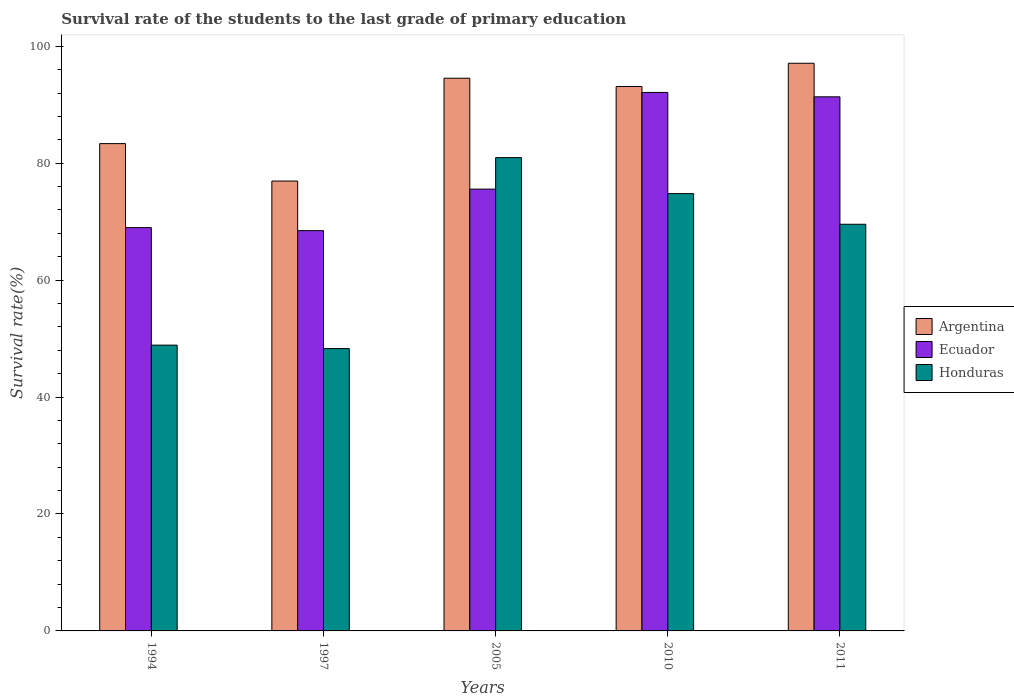How many different coloured bars are there?
Keep it short and to the point. 3. How many bars are there on the 5th tick from the left?
Your answer should be very brief. 3. How many bars are there on the 4th tick from the right?
Give a very brief answer. 3. In how many cases, is the number of bars for a given year not equal to the number of legend labels?
Give a very brief answer. 0. What is the survival rate of the students in Argentina in 2010?
Keep it short and to the point. 93.12. Across all years, what is the maximum survival rate of the students in Honduras?
Make the answer very short. 80.96. Across all years, what is the minimum survival rate of the students in Argentina?
Your answer should be compact. 76.95. In which year was the survival rate of the students in Ecuador maximum?
Keep it short and to the point. 2010. What is the total survival rate of the students in Ecuador in the graph?
Offer a terse response. 396.48. What is the difference between the survival rate of the students in Honduras in 2010 and that in 2011?
Provide a short and direct response. 5.24. What is the difference between the survival rate of the students in Argentina in 2011 and the survival rate of the students in Ecuador in 1997?
Your response must be concise. 28.63. What is the average survival rate of the students in Argentina per year?
Ensure brevity in your answer.  89.01. In the year 2005, what is the difference between the survival rate of the students in Ecuador and survival rate of the students in Argentina?
Provide a short and direct response. -18.97. What is the ratio of the survival rate of the students in Ecuador in 2010 to that in 2011?
Your response must be concise. 1.01. Is the survival rate of the students in Argentina in 1994 less than that in 2010?
Give a very brief answer. Yes. What is the difference between the highest and the second highest survival rate of the students in Ecuador?
Your response must be concise. 0.75. What is the difference between the highest and the lowest survival rate of the students in Ecuador?
Ensure brevity in your answer.  23.63. Is the sum of the survival rate of the students in Argentina in 1997 and 2005 greater than the maximum survival rate of the students in Ecuador across all years?
Your answer should be compact. Yes. What does the 1st bar from the right in 2010 represents?
Your answer should be very brief. Honduras. Are all the bars in the graph horizontal?
Your answer should be compact. No. Does the graph contain grids?
Your answer should be compact. No. How many legend labels are there?
Make the answer very short. 3. What is the title of the graph?
Provide a succinct answer. Survival rate of the students to the last grade of primary education. Does "Bosnia and Herzegovina" appear as one of the legend labels in the graph?
Provide a short and direct response. No. What is the label or title of the X-axis?
Offer a terse response. Years. What is the label or title of the Y-axis?
Provide a short and direct response. Survival rate(%). What is the Survival rate(%) in Argentina in 1994?
Your response must be concise. 83.35. What is the Survival rate(%) of Ecuador in 1994?
Offer a terse response. 68.98. What is the Survival rate(%) of Honduras in 1994?
Ensure brevity in your answer.  48.88. What is the Survival rate(%) in Argentina in 1997?
Make the answer very short. 76.95. What is the Survival rate(%) of Ecuador in 1997?
Ensure brevity in your answer.  68.47. What is the Survival rate(%) in Honduras in 1997?
Your answer should be very brief. 48.29. What is the Survival rate(%) in Argentina in 2005?
Your response must be concise. 94.54. What is the Survival rate(%) of Ecuador in 2005?
Your answer should be very brief. 75.57. What is the Survival rate(%) of Honduras in 2005?
Your answer should be very brief. 80.96. What is the Survival rate(%) in Argentina in 2010?
Provide a short and direct response. 93.12. What is the Survival rate(%) of Ecuador in 2010?
Offer a terse response. 92.1. What is the Survival rate(%) in Honduras in 2010?
Provide a short and direct response. 74.8. What is the Survival rate(%) in Argentina in 2011?
Your answer should be compact. 97.1. What is the Survival rate(%) in Ecuador in 2011?
Provide a short and direct response. 91.36. What is the Survival rate(%) in Honduras in 2011?
Offer a very short reply. 69.56. Across all years, what is the maximum Survival rate(%) in Argentina?
Give a very brief answer. 97.1. Across all years, what is the maximum Survival rate(%) of Ecuador?
Make the answer very short. 92.1. Across all years, what is the maximum Survival rate(%) of Honduras?
Provide a short and direct response. 80.96. Across all years, what is the minimum Survival rate(%) of Argentina?
Give a very brief answer. 76.95. Across all years, what is the minimum Survival rate(%) of Ecuador?
Offer a terse response. 68.47. Across all years, what is the minimum Survival rate(%) in Honduras?
Make the answer very short. 48.29. What is the total Survival rate(%) in Argentina in the graph?
Offer a very short reply. 445.06. What is the total Survival rate(%) in Ecuador in the graph?
Provide a short and direct response. 396.48. What is the total Survival rate(%) in Honduras in the graph?
Ensure brevity in your answer.  322.49. What is the difference between the Survival rate(%) of Argentina in 1994 and that in 1997?
Ensure brevity in your answer.  6.4. What is the difference between the Survival rate(%) in Ecuador in 1994 and that in 1997?
Offer a very short reply. 0.51. What is the difference between the Survival rate(%) of Honduras in 1994 and that in 1997?
Your answer should be very brief. 0.59. What is the difference between the Survival rate(%) in Argentina in 1994 and that in 2005?
Your answer should be very brief. -11.19. What is the difference between the Survival rate(%) of Ecuador in 1994 and that in 2005?
Offer a terse response. -6.59. What is the difference between the Survival rate(%) in Honduras in 1994 and that in 2005?
Provide a short and direct response. -32.07. What is the difference between the Survival rate(%) of Argentina in 1994 and that in 2010?
Make the answer very short. -9.76. What is the difference between the Survival rate(%) of Ecuador in 1994 and that in 2010?
Offer a very short reply. -23.12. What is the difference between the Survival rate(%) of Honduras in 1994 and that in 2010?
Make the answer very short. -25.92. What is the difference between the Survival rate(%) of Argentina in 1994 and that in 2011?
Your answer should be very brief. -13.74. What is the difference between the Survival rate(%) in Ecuador in 1994 and that in 2011?
Provide a succinct answer. -22.37. What is the difference between the Survival rate(%) of Honduras in 1994 and that in 2011?
Keep it short and to the point. -20.68. What is the difference between the Survival rate(%) in Argentina in 1997 and that in 2005?
Make the answer very short. -17.59. What is the difference between the Survival rate(%) of Ecuador in 1997 and that in 2005?
Your answer should be compact. -7.1. What is the difference between the Survival rate(%) in Honduras in 1997 and that in 2005?
Offer a very short reply. -32.66. What is the difference between the Survival rate(%) of Argentina in 1997 and that in 2010?
Make the answer very short. -16.17. What is the difference between the Survival rate(%) in Ecuador in 1997 and that in 2010?
Your response must be concise. -23.63. What is the difference between the Survival rate(%) in Honduras in 1997 and that in 2010?
Provide a short and direct response. -26.51. What is the difference between the Survival rate(%) of Argentina in 1997 and that in 2011?
Offer a terse response. -20.15. What is the difference between the Survival rate(%) in Ecuador in 1997 and that in 2011?
Provide a succinct answer. -22.89. What is the difference between the Survival rate(%) of Honduras in 1997 and that in 2011?
Keep it short and to the point. -21.26. What is the difference between the Survival rate(%) of Argentina in 2005 and that in 2010?
Provide a succinct answer. 1.42. What is the difference between the Survival rate(%) of Ecuador in 2005 and that in 2010?
Ensure brevity in your answer.  -16.53. What is the difference between the Survival rate(%) in Honduras in 2005 and that in 2010?
Ensure brevity in your answer.  6.16. What is the difference between the Survival rate(%) in Argentina in 2005 and that in 2011?
Your response must be concise. -2.56. What is the difference between the Survival rate(%) in Ecuador in 2005 and that in 2011?
Keep it short and to the point. -15.78. What is the difference between the Survival rate(%) of Honduras in 2005 and that in 2011?
Give a very brief answer. 11.4. What is the difference between the Survival rate(%) of Argentina in 2010 and that in 2011?
Keep it short and to the point. -3.98. What is the difference between the Survival rate(%) in Ecuador in 2010 and that in 2011?
Keep it short and to the point. 0.75. What is the difference between the Survival rate(%) in Honduras in 2010 and that in 2011?
Offer a terse response. 5.24. What is the difference between the Survival rate(%) in Argentina in 1994 and the Survival rate(%) in Ecuador in 1997?
Your answer should be compact. 14.88. What is the difference between the Survival rate(%) of Argentina in 1994 and the Survival rate(%) of Honduras in 1997?
Make the answer very short. 35.06. What is the difference between the Survival rate(%) in Ecuador in 1994 and the Survival rate(%) in Honduras in 1997?
Provide a succinct answer. 20.69. What is the difference between the Survival rate(%) in Argentina in 1994 and the Survival rate(%) in Ecuador in 2005?
Provide a succinct answer. 7.78. What is the difference between the Survival rate(%) of Argentina in 1994 and the Survival rate(%) of Honduras in 2005?
Offer a very short reply. 2.4. What is the difference between the Survival rate(%) of Ecuador in 1994 and the Survival rate(%) of Honduras in 2005?
Provide a short and direct response. -11.97. What is the difference between the Survival rate(%) in Argentina in 1994 and the Survival rate(%) in Ecuador in 2010?
Your answer should be compact. -8.75. What is the difference between the Survival rate(%) in Argentina in 1994 and the Survival rate(%) in Honduras in 2010?
Your response must be concise. 8.55. What is the difference between the Survival rate(%) of Ecuador in 1994 and the Survival rate(%) of Honduras in 2010?
Provide a succinct answer. -5.82. What is the difference between the Survival rate(%) of Argentina in 1994 and the Survival rate(%) of Ecuador in 2011?
Your answer should be compact. -8. What is the difference between the Survival rate(%) of Argentina in 1994 and the Survival rate(%) of Honduras in 2011?
Offer a very short reply. 13.8. What is the difference between the Survival rate(%) in Ecuador in 1994 and the Survival rate(%) in Honduras in 2011?
Ensure brevity in your answer.  -0.57. What is the difference between the Survival rate(%) of Argentina in 1997 and the Survival rate(%) of Ecuador in 2005?
Make the answer very short. 1.38. What is the difference between the Survival rate(%) in Argentina in 1997 and the Survival rate(%) in Honduras in 2005?
Offer a terse response. -4.01. What is the difference between the Survival rate(%) of Ecuador in 1997 and the Survival rate(%) of Honduras in 2005?
Give a very brief answer. -12.49. What is the difference between the Survival rate(%) of Argentina in 1997 and the Survival rate(%) of Ecuador in 2010?
Make the answer very short. -15.15. What is the difference between the Survival rate(%) in Argentina in 1997 and the Survival rate(%) in Honduras in 2010?
Your answer should be compact. 2.15. What is the difference between the Survival rate(%) in Ecuador in 1997 and the Survival rate(%) in Honduras in 2010?
Your response must be concise. -6.33. What is the difference between the Survival rate(%) in Argentina in 1997 and the Survival rate(%) in Ecuador in 2011?
Offer a terse response. -14.41. What is the difference between the Survival rate(%) of Argentina in 1997 and the Survival rate(%) of Honduras in 2011?
Keep it short and to the point. 7.39. What is the difference between the Survival rate(%) in Ecuador in 1997 and the Survival rate(%) in Honduras in 2011?
Make the answer very short. -1.09. What is the difference between the Survival rate(%) in Argentina in 2005 and the Survival rate(%) in Ecuador in 2010?
Keep it short and to the point. 2.44. What is the difference between the Survival rate(%) of Argentina in 2005 and the Survival rate(%) of Honduras in 2010?
Offer a terse response. 19.74. What is the difference between the Survival rate(%) in Ecuador in 2005 and the Survival rate(%) in Honduras in 2010?
Provide a succinct answer. 0.77. What is the difference between the Survival rate(%) of Argentina in 2005 and the Survival rate(%) of Ecuador in 2011?
Your response must be concise. 3.19. What is the difference between the Survival rate(%) of Argentina in 2005 and the Survival rate(%) of Honduras in 2011?
Make the answer very short. 24.98. What is the difference between the Survival rate(%) in Ecuador in 2005 and the Survival rate(%) in Honduras in 2011?
Give a very brief answer. 6.01. What is the difference between the Survival rate(%) of Argentina in 2010 and the Survival rate(%) of Ecuador in 2011?
Provide a succinct answer. 1.76. What is the difference between the Survival rate(%) in Argentina in 2010 and the Survival rate(%) in Honduras in 2011?
Offer a terse response. 23.56. What is the difference between the Survival rate(%) in Ecuador in 2010 and the Survival rate(%) in Honduras in 2011?
Offer a terse response. 22.55. What is the average Survival rate(%) in Argentina per year?
Ensure brevity in your answer.  89.01. What is the average Survival rate(%) of Ecuador per year?
Provide a succinct answer. 79.3. What is the average Survival rate(%) in Honduras per year?
Give a very brief answer. 64.5. In the year 1994, what is the difference between the Survival rate(%) in Argentina and Survival rate(%) in Ecuador?
Give a very brief answer. 14.37. In the year 1994, what is the difference between the Survival rate(%) in Argentina and Survival rate(%) in Honduras?
Ensure brevity in your answer.  34.47. In the year 1994, what is the difference between the Survival rate(%) in Ecuador and Survival rate(%) in Honduras?
Your response must be concise. 20.1. In the year 1997, what is the difference between the Survival rate(%) of Argentina and Survival rate(%) of Ecuador?
Offer a very short reply. 8.48. In the year 1997, what is the difference between the Survival rate(%) in Argentina and Survival rate(%) in Honduras?
Your response must be concise. 28.66. In the year 1997, what is the difference between the Survival rate(%) in Ecuador and Survival rate(%) in Honduras?
Ensure brevity in your answer.  20.18. In the year 2005, what is the difference between the Survival rate(%) in Argentina and Survival rate(%) in Ecuador?
Keep it short and to the point. 18.97. In the year 2005, what is the difference between the Survival rate(%) of Argentina and Survival rate(%) of Honduras?
Offer a very short reply. 13.59. In the year 2005, what is the difference between the Survival rate(%) of Ecuador and Survival rate(%) of Honduras?
Your answer should be compact. -5.38. In the year 2010, what is the difference between the Survival rate(%) in Argentina and Survival rate(%) in Honduras?
Ensure brevity in your answer.  18.32. In the year 2010, what is the difference between the Survival rate(%) of Ecuador and Survival rate(%) of Honduras?
Your response must be concise. 17.3. In the year 2011, what is the difference between the Survival rate(%) of Argentina and Survival rate(%) of Ecuador?
Your answer should be very brief. 5.74. In the year 2011, what is the difference between the Survival rate(%) of Argentina and Survival rate(%) of Honduras?
Offer a terse response. 27.54. In the year 2011, what is the difference between the Survival rate(%) of Ecuador and Survival rate(%) of Honduras?
Make the answer very short. 21.8. What is the ratio of the Survival rate(%) in Argentina in 1994 to that in 1997?
Give a very brief answer. 1.08. What is the ratio of the Survival rate(%) of Ecuador in 1994 to that in 1997?
Give a very brief answer. 1.01. What is the ratio of the Survival rate(%) in Honduras in 1994 to that in 1997?
Provide a short and direct response. 1.01. What is the ratio of the Survival rate(%) of Argentina in 1994 to that in 2005?
Provide a succinct answer. 0.88. What is the ratio of the Survival rate(%) of Ecuador in 1994 to that in 2005?
Your answer should be very brief. 0.91. What is the ratio of the Survival rate(%) in Honduras in 1994 to that in 2005?
Ensure brevity in your answer.  0.6. What is the ratio of the Survival rate(%) in Argentina in 1994 to that in 2010?
Make the answer very short. 0.9. What is the ratio of the Survival rate(%) in Ecuador in 1994 to that in 2010?
Your answer should be compact. 0.75. What is the ratio of the Survival rate(%) in Honduras in 1994 to that in 2010?
Ensure brevity in your answer.  0.65. What is the ratio of the Survival rate(%) in Argentina in 1994 to that in 2011?
Provide a short and direct response. 0.86. What is the ratio of the Survival rate(%) in Ecuador in 1994 to that in 2011?
Your response must be concise. 0.76. What is the ratio of the Survival rate(%) in Honduras in 1994 to that in 2011?
Your response must be concise. 0.7. What is the ratio of the Survival rate(%) in Argentina in 1997 to that in 2005?
Provide a succinct answer. 0.81. What is the ratio of the Survival rate(%) of Ecuador in 1997 to that in 2005?
Provide a succinct answer. 0.91. What is the ratio of the Survival rate(%) in Honduras in 1997 to that in 2005?
Your answer should be compact. 0.6. What is the ratio of the Survival rate(%) of Argentina in 1997 to that in 2010?
Your response must be concise. 0.83. What is the ratio of the Survival rate(%) in Ecuador in 1997 to that in 2010?
Offer a terse response. 0.74. What is the ratio of the Survival rate(%) of Honduras in 1997 to that in 2010?
Offer a very short reply. 0.65. What is the ratio of the Survival rate(%) of Argentina in 1997 to that in 2011?
Provide a short and direct response. 0.79. What is the ratio of the Survival rate(%) of Ecuador in 1997 to that in 2011?
Your response must be concise. 0.75. What is the ratio of the Survival rate(%) in Honduras in 1997 to that in 2011?
Offer a terse response. 0.69. What is the ratio of the Survival rate(%) in Argentina in 2005 to that in 2010?
Your answer should be compact. 1.02. What is the ratio of the Survival rate(%) in Ecuador in 2005 to that in 2010?
Offer a terse response. 0.82. What is the ratio of the Survival rate(%) of Honduras in 2005 to that in 2010?
Offer a very short reply. 1.08. What is the ratio of the Survival rate(%) of Argentina in 2005 to that in 2011?
Make the answer very short. 0.97. What is the ratio of the Survival rate(%) of Ecuador in 2005 to that in 2011?
Your answer should be compact. 0.83. What is the ratio of the Survival rate(%) in Honduras in 2005 to that in 2011?
Ensure brevity in your answer.  1.16. What is the ratio of the Survival rate(%) of Ecuador in 2010 to that in 2011?
Ensure brevity in your answer.  1.01. What is the ratio of the Survival rate(%) in Honduras in 2010 to that in 2011?
Give a very brief answer. 1.08. What is the difference between the highest and the second highest Survival rate(%) in Argentina?
Give a very brief answer. 2.56. What is the difference between the highest and the second highest Survival rate(%) in Ecuador?
Offer a terse response. 0.75. What is the difference between the highest and the second highest Survival rate(%) of Honduras?
Give a very brief answer. 6.16. What is the difference between the highest and the lowest Survival rate(%) of Argentina?
Ensure brevity in your answer.  20.15. What is the difference between the highest and the lowest Survival rate(%) of Ecuador?
Provide a succinct answer. 23.63. What is the difference between the highest and the lowest Survival rate(%) of Honduras?
Provide a short and direct response. 32.66. 